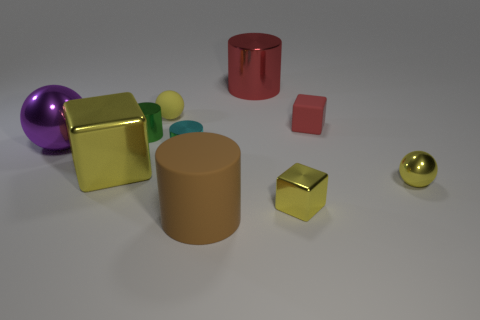Which objects in the image are reflective? The objects with a reflective surface include the purple sphere, the golden cube on the left, and the small golden sphere on the right. They exhibit a glossy finish that catches the light and creates noticeable reflections. 